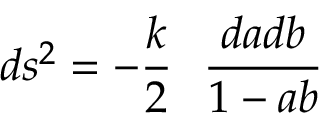<formula> <loc_0><loc_0><loc_500><loc_500>d s ^ { 2 } = - \frac { k } { 2 } \quad f r a c { d a d b } { 1 - a b }</formula> 